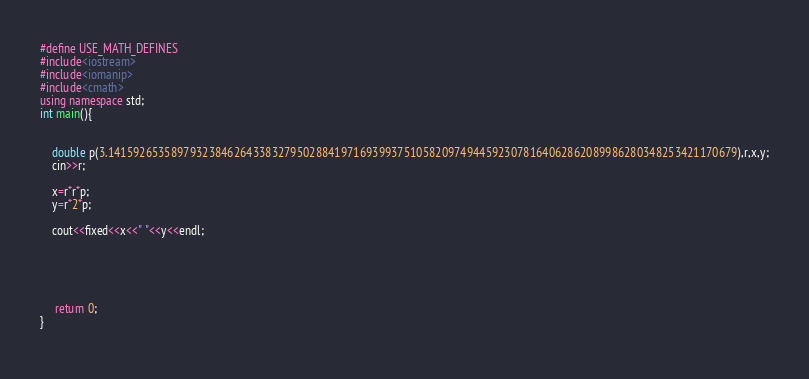<code> <loc_0><loc_0><loc_500><loc_500><_C++_>#define USE_MATH_DEFINES
#include<iostream>
#include<iomanip>
#include<cmath>                    
using namespace std;
int main(){
    

    double p(3.1415926535897932384626433832795028841971693993751058209749445923078164062862089986280348253421170679),r,x,y;
    cin>>r;

	x=r*r*p;
	y=r*2*p;

	cout<<fixed<<x<<" "<<y<<endl;

	
   


	 return 0;
}
 
</code> 